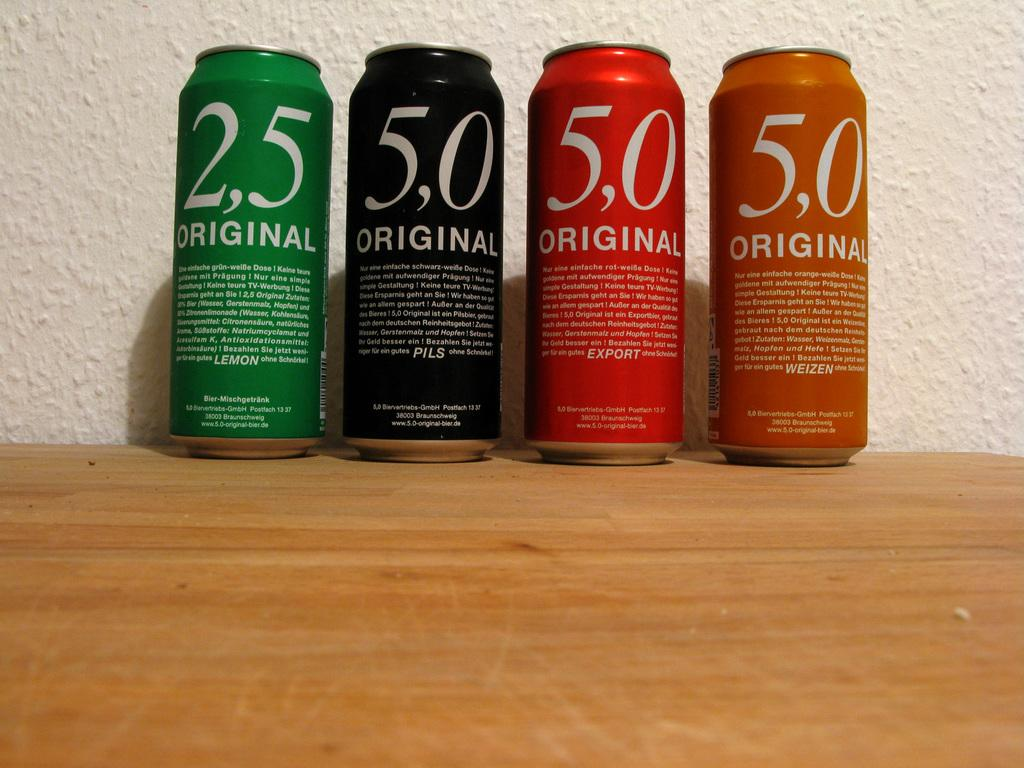<image>
Give a short and clear explanation of the subsequent image. An assortment of 4 cans with 5,0 on 3 cans and 2,5 on one. 